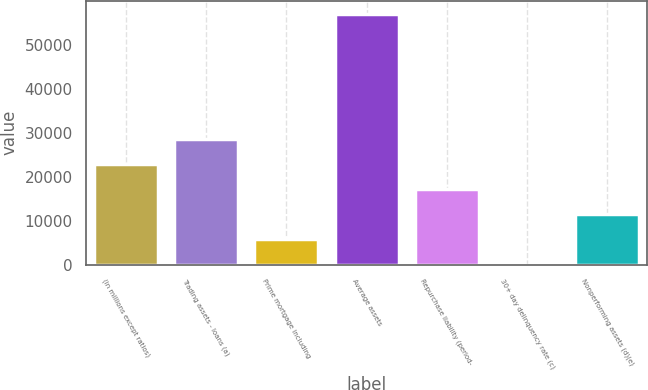Convert chart to OTSL. <chart><loc_0><loc_0><loc_500><loc_500><bar_chart><fcel>(in millions except ratios)<fcel>Trading assets - loans (a)<fcel>Prime mortgage including<fcel>Average assets<fcel>Repurchase liability (period-<fcel>30+ day delinquency rate (c)<fcel>Nonperforming assets (d)(e)<nl><fcel>22854.1<fcel>28566.9<fcel>5715.58<fcel>57131<fcel>17141.2<fcel>2.75<fcel>11428.4<nl></chart> 